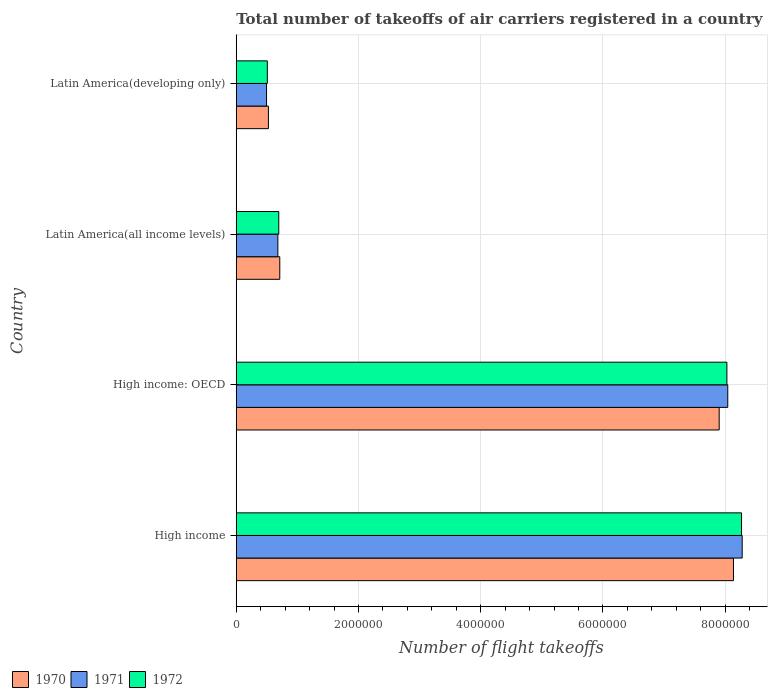How many different coloured bars are there?
Offer a very short reply. 3. How many groups of bars are there?
Your response must be concise. 4. Are the number of bars per tick equal to the number of legend labels?
Give a very brief answer. Yes. What is the label of the 3rd group of bars from the top?
Your answer should be very brief. High income: OECD. In how many cases, is the number of bars for a given country not equal to the number of legend labels?
Your answer should be very brief. 0. What is the total number of flight takeoffs in 1972 in Latin America(developing only)?
Your answer should be compact. 5.08e+05. Across all countries, what is the maximum total number of flight takeoffs in 1971?
Keep it short and to the point. 8.28e+06. Across all countries, what is the minimum total number of flight takeoffs in 1972?
Keep it short and to the point. 5.08e+05. In which country was the total number of flight takeoffs in 1971 minimum?
Make the answer very short. Latin America(developing only). What is the total total number of flight takeoffs in 1970 in the graph?
Your answer should be very brief. 1.73e+07. What is the difference between the total number of flight takeoffs in 1970 in Latin America(all income levels) and that in Latin America(developing only)?
Give a very brief answer. 1.86e+05. What is the difference between the total number of flight takeoffs in 1970 in High income: OECD and the total number of flight takeoffs in 1971 in High income?
Provide a succinct answer. -3.76e+05. What is the average total number of flight takeoffs in 1971 per country?
Give a very brief answer. 4.37e+06. What is the difference between the total number of flight takeoffs in 1970 and total number of flight takeoffs in 1971 in High income: OECD?
Give a very brief answer. -1.40e+05. What is the ratio of the total number of flight takeoffs in 1970 in High income to that in High income: OECD?
Offer a terse response. 1.03. What is the difference between the highest and the second highest total number of flight takeoffs in 1971?
Keep it short and to the point. 2.36e+05. What is the difference between the highest and the lowest total number of flight takeoffs in 1970?
Give a very brief answer. 7.61e+06. In how many countries, is the total number of flight takeoffs in 1971 greater than the average total number of flight takeoffs in 1971 taken over all countries?
Offer a terse response. 2. Is the sum of the total number of flight takeoffs in 1972 in High income and High income: OECD greater than the maximum total number of flight takeoffs in 1970 across all countries?
Keep it short and to the point. Yes. How many bars are there?
Make the answer very short. 12. How many countries are there in the graph?
Your answer should be very brief. 4. What is the difference between two consecutive major ticks on the X-axis?
Your response must be concise. 2.00e+06. Are the values on the major ticks of X-axis written in scientific E-notation?
Keep it short and to the point. No. Does the graph contain any zero values?
Your response must be concise. No. Does the graph contain grids?
Ensure brevity in your answer.  Yes. Where does the legend appear in the graph?
Provide a succinct answer. Bottom left. What is the title of the graph?
Your answer should be compact. Total number of takeoffs of air carriers registered in a country. What is the label or title of the X-axis?
Give a very brief answer. Number of flight takeoffs. What is the Number of flight takeoffs in 1970 in High income?
Your response must be concise. 8.14e+06. What is the Number of flight takeoffs in 1971 in High income?
Offer a very short reply. 8.28e+06. What is the Number of flight takeoffs of 1972 in High income?
Offer a terse response. 8.27e+06. What is the Number of flight takeoffs of 1970 in High income: OECD?
Offer a terse response. 7.90e+06. What is the Number of flight takeoffs of 1971 in High income: OECD?
Provide a short and direct response. 8.04e+06. What is the Number of flight takeoffs in 1972 in High income: OECD?
Ensure brevity in your answer.  8.03e+06. What is the Number of flight takeoffs in 1970 in Latin America(all income levels)?
Keep it short and to the point. 7.12e+05. What is the Number of flight takeoffs of 1971 in Latin America(all income levels)?
Give a very brief answer. 6.81e+05. What is the Number of flight takeoffs in 1972 in Latin America(all income levels)?
Keep it short and to the point. 6.96e+05. What is the Number of flight takeoffs of 1970 in Latin America(developing only)?
Provide a short and direct response. 5.26e+05. What is the Number of flight takeoffs of 1971 in Latin America(developing only)?
Make the answer very short. 4.95e+05. What is the Number of flight takeoffs of 1972 in Latin America(developing only)?
Offer a terse response. 5.08e+05. Across all countries, what is the maximum Number of flight takeoffs in 1970?
Your answer should be compact. 8.14e+06. Across all countries, what is the maximum Number of flight takeoffs in 1971?
Provide a succinct answer. 8.28e+06. Across all countries, what is the maximum Number of flight takeoffs of 1972?
Provide a short and direct response. 8.27e+06. Across all countries, what is the minimum Number of flight takeoffs in 1970?
Your answer should be compact. 5.26e+05. Across all countries, what is the minimum Number of flight takeoffs of 1971?
Your response must be concise. 4.95e+05. Across all countries, what is the minimum Number of flight takeoffs of 1972?
Offer a terse response. 5.08e+05. What is the total Number of flight takeoffs of 1970 in the graph?
Your answer should be very brief. 1.73e+07. What is the total Number of flight takeoffs of 1971 in the graph?
Your answer should be very brief. 1.75e+07. What is the total Number of flight takeoffs of 1972 in the graph?
Your response must be concise. 1.75e+07. What is the difference between the Number of flight takeoffs of 1970 in High income and that in High income: OECD?
Provide a succinct answer. 2.34e+05. What is the difference between the Number of flight takeoffs of 1971 in High income and that in High income: OECD?
Ensure brevity in your answer.  2.36e+05. What is the difference between the Number of flight takeoffs of 1972 in High income and that in High income: OECD?
Your response must be concise. 2.40e+05. What is the difference between the Number of flight takeoffs in 1970 in High income and that in Latin America(all income levels)?
Your response must be concise. 7.42e+06. What is the difference between the Number of flight takeoffs in 1971 in High income and that in Latin America(all income levels)?
Ensure brevity in your answer.  7.60e+06. What is the difference between the Number of flight takeoffs in 1972 in High income and that in Latin America(all income levels)?
Your response must be concise. 7.57e+06. What is the difference between the Number of flight takeoffs of 1970 in High income and that in Latin America(developing only)?
Provide a succinct answer. 7.61e+06. What is the difference between the Number of flight takeoffs in 1971 in High income and that in Latin America(developing only)?
Ensure brevity in your answer.  7.78e+06. What is the difference between the Number of flight takeoffs of 1972 in High income and that in Latin America(developing only)?
Your answer should be compact. 7.76e+06. What is the difference between the Number of flight takeoffs in 1970 in High income: OECD and that in Latin America(all income levels)?
Ensure brevity in your answer.  7.19e+06. What is the difference between the Number of flight takeoffs of 1971 in High income: OECD and that in Latin America(all income levels)?
Your answer should be compact. 7.36e+06. What is the difference between the Number of flight takeoffs in 1972 in High income: OECD and that in Latin America(all income levels)?
Your response must be concise. 7.33e+06. What is the difference between the Number of flight takeoffs in 1970 in High income: OECD and that in Latin America(developing only)?
Offer a terse response. 7.38e+06. What is the difference between the Number of flight takeoffs of 1971 in High income: OECD and that in Latin America(developing only)?
Make the answer very short. 7.55e+06. What is the difference between the Number of flight takeoffs in 1972 in High income: OECD and that in Latin America(developing only)?
Give a very brief answer. 7.52e+06. What is the difference between the Number of flight takeoffs in 1970 in Latin America(all income levels) and that in Latin America(developing only)?
Provide a short and direct response. 1.86e+05. What is the difference between the Number of flight takeoffs in 1971 in Latin America(all income levels) and that in Latin America(developing only)?
Ensure brevity in your answer.  1.86e+05. What is the difference between the Number of flight takeoffs of 1972 in Latin America(all income levels) and that in Latin America(developing only)?
Your response must be concise. 1.87e+05. What is the difference between the Number of flight takeoffs in 1970 in High income and the Number of flight takeoffs in 1971 in High income: OECD?
Your answer should be very brief. 9.37e+04. What is the difference between the Number of flight takeoffs of 1970 in High income and the Number of flight takeoffs of 1972 in High income: OECD?
Offer a very short reply. 1.08e+05. What is the difference between the Number of flight takeoffs in 1971 in High income and the Number of flight takeoffs in 1972 in High income: OECD?
Make the answer very short. 2.50e+05. What is the difference between the Number of flight takeoffs in 1970 in High income and the Number of flight takeoffs in 1971 in Latin America(all income levels)?
Ensure brevity in your answer.  7.46e+06. What is the difference between the Number of flight takeoffs in 1970 in High income and the Number of flight takeoffs in 1972 in Latin America(all income levels)?
Make the answer very short. 7.44e+06. What is the difference between the Number of flight takeoffs of 1971 in High income and the Number of flight takeoffs of 1972 in Latin America(all income levels)?
Your response must be concise. 7.58e+06. What is the difference between the Number of flight takeoffs of 1970 in High income and the Number of flight takeoffs of 1971 in Latin America(developing only)?
Provide a short and direct response. 7.64e+06. What is the difference between the Number of flight takeoffs in 1970 in High income and the Number of flight takeoffs in 1972 in Latin America(developing only)?
Your response must be concise. 7.63e+06. What is the difference between the Number of flight takeoffs in 1971 in High income and the Number of flight takeoffs in 1972 in Latin America(developing only)?
Keep it short and to the point. 7.77e+06. What is the difference between the Number of flight takeoffs in 1970 in High income: OECD and the Number of flight takeoffs in 1971 in Latin America(all income levels)?
Keep it short and to the point. 7.22e+06. What is the difference between the Number of flight takeoffs in 1970 in High income: OECD and the Number of flight takeoffs in 1972 in Latin America(all income levels)?
Provide a succinct answer. 7.21e+06. What is the difference between the Number of flight takeoffs of 1971 in High income: OECD and the Number of flight takeoffs of 1972 in Latin America(all income levels)?
Give a very brief answer. 7.35e+06. What is the difference between the Number of flight takeoffs of 1970 in High income: OECD and the Number of flight takeoffs of 1971 in Latin America(developing only)?
Provide a short and direct response. 7.41e+06. What is the difference between the Number of flight takeoffs in 1970 in High income: OECD and the Number of flight takeoffs in 1972 in Latin America(developing only)?
Your response must be concise. 7.39e+06. What is the difference between the Number of flight takeoffs in 1971 in High income: OECD and the Number of flight takeoffs in 1972 in Latin America(developing only)?
Provide a succinct answer. 7.53e+06. What is the difference between the Number of flight takeoffs of 1970 in Latin America(all income levels) and the Number of flight takeoffs of 1971 in Latin America(developing only)?
Your response must be concise. 2.17e+05. What is the difference between the Number of flight takeoffs of 1970 in Latin America(all income levels) and the Number of flight takeoffs of 1972 in Latin America(developing only)?
Your answer should be compact. 2.04e+05. What is the difference between the Number of flight takeoffs of 1971 in Latin America(all income levels) and the Number of flight takeoffs of 1972 in Latin America(developing only)?
Provide a succinct answer. 1.73e+05. What is the average Number of flight takeoffs in 1970 per country?
Offer a terse response. 4.32e+06. What is the average Number of flight takeoffs in 1971 per country?
Provide a short and direct response. 4.37e+06. What is the average Number of flight takeoffs of 1972 per country?
Keep it short and to the point. 4.37e+06. What is the difference between the Number of flight takeoffs of 1970 and Number of flight takeoffs of 1971 in High income?
Offer a terse response. -1.42e+05. What is the difference between the Number of flight takeoffs of 1970 and Number of flight takeoffs of 1972 in High income?
Your answer should be compact. -1.32e+05. What is the difference between the Number of flight takeoffs in 1971 and Number of flight takeoffs in 1972 in High income?
Give a very brief answer. 1.09e+04. What is the difference between the Number of flight takeoffs of 1970 and Number of flight takeoffs of 1971 in High income: OECD?
Give a very brief answer. -1.40e+05. What is the difference between the Number of flight takeoffs in 1970 and Number of flight takeoffs in 1972 in High income: OECD?
Make the answer very short. -1.26e+05. What is the difference between the Number of flight takeoffs of 1971 and Number of flight takeoffs of 1972 in High income: OECD?
Offer a very short reply. 1.43e+04. What is the difference between the Number of flight takeoffs of 1970 and Number of flight takeoffs of 1971 in Latin America(all income levels)?
Your answer should be compact. 3.13e+04. What is the difference between the Number of flight takeoffs of 1970 and Number of flight takeoffs of 1972 in Latin America(all income levels)?
Your answer should be compact. 1.68e+04. What is the difference between the Number of flight takeoffs of 1971 and Number of flight takeoffs of 1972 in Latin America(all income levels)?
Your answer should be compact. -1.45e+04. What is the difference between the Number of flight takeoffs of 1970 and Number of flight takeoffs of 1971 in Latin America(developing only)?
Keep it short and to the point. 3.09e+04. What is the difference between the Number of flight takeoffs in 1970 and Number of flight takeoffs in 1972 in Latin America(developing only)?
Your answer should be compact. 1.79e+04. What is the difference between the Number of flight takeoffs in 1971 and Number of flight takeoffs in 1972 in Latin America(developing only)?
Provide a short and direct response. -1.30e+04. What is the ratio of the Number of flight takeoffs in 1970 in High income to that in High income: OECD?
Make the answer very short. 1.03. What is the ratio of the Number of flight takeoffs of 1971 in High income to that in High income: OECD?
Give a very brief answer. 1.03. What is the ratio of the Number of flight takeoffs in 1972 in High income to that in High income: OECD?
Your response must be concise. 1.03. What is the ratio of the Number of flight takeoffs of 1970 in High income to that in Latin America(all income levels)?
Provide a short and direct response. 11.42. What is the ratio of the Number of flight takeoffs in 1971 in High income to that in Latin America(all income levels)?
Keep it short and to the point. 12.16. What is the ratio of the Number of flight takeoffs in 1972 in High income to that in Latin America(all income levels)?
Your answer should be very brief. 11.89. What is the ratio of the Number of flight takeoffs in 1970 in High income to that in Latin America(developing only)?
Offer a terse response. 15.46. What is the ratio of the Number of flight takeoffs in 1971 in High income to that in Latin America(developing only)?
Ensure brevity in your answer.  16.71. What is the ratio of the Number of flight takeoffs in 1972 in High income to that in Latin America(developing only)?
Make the answer very short. 16.26. What is the ratio of the Number of flight takeoffs in 1970 in High income: OECD to that in Latin America(all income levels)?
Ensure brevity in your answer.  11.09. What is the ratio of the Number of flight takeoffs in 1971 in High income: OECD to that in Latin America(all income levels)?
Your response must be concise. 11.81. What is the ratio of the Number of flight takeoffs in 1972 in High income: OECD to that in Latin America(all income levels)?
Your answer should be very brief. 11.54. What is the ratio of the Number of flight takeoffs in 1970 in High income: OECD to that in Latin America(developing only)?
Ensure brevity in your answer.  15.01. What is the ratio of the Number of flight takeoffs in 1971 in High income: OECD to that in Latin America(developing only)?
Offer a very short reply. 16.23. What is the ratio of the Number of flight takeoffs in 1972 in High income: OECD to that in Latin America(developing only)?
Your answer should be compact. 15.79. What is the ratio of the Number of flight takeoffs in 1970 in Latin America(all income levels) to that in Latin America(developing only)?
Offer a very short reply. 1.35. What is the ratio of the Number of flight takeoffs in 1971 in Latin America(all income levels) to that in Latin America(developing only)?
Your answer should be compact. 1.37. What is the ratio of the Number of flight takeoffs of 1972 in Latin America(all income levels) to that in Latin America(developing only)?
Offer a terse response. 1.37. What is the difference between the highest and the second highest Number of flight takeoffs of 1970?
Ensure brevity in your answer.  2.34e+05. What is the difference between the highest and the second highest Number of flight takeoffs in 1971?
Your response must be concise. 2.36e+05. What is the difference between the highest and the second highest Number of flight takeoffs in 1972?
Offer a terse response. 2.40e+05. What is the difference between the highest and the lowest Number of flight takeoffs of 1970?
Your answer should be very brief. 7.61e+06. What is the difference between the highest and the lowest Number of flight takeoffs in 1971?
Your answer should be very brief. 7.78e+06. What is the difference between the highest and the lowest Number of flight takeoffs of 1972?
Make the answer very short. 7.76e+06. 